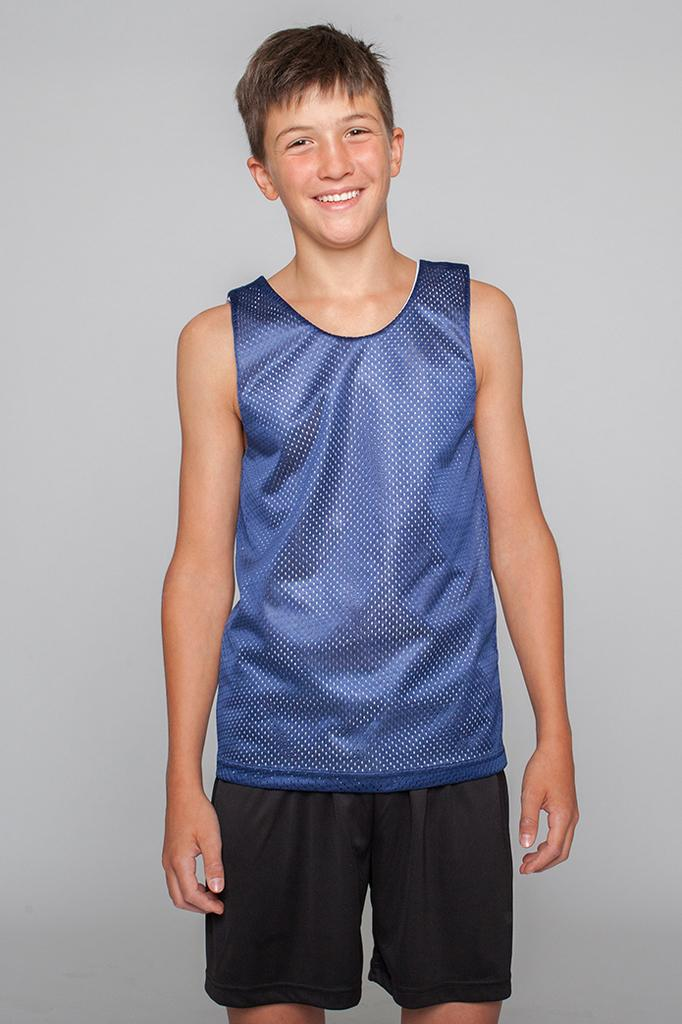What is the main subject of the picture? The main subject of the picture is a boy. What is the boy doing in the picture? The boy is standing in the picture. How does the boy appear to be feeling in the picture? The boy has a smile on his face, indicating that he is happy. What can be seen behind the boy in the picture? The background of the image is plain. What type of jeans is the boy wearing in the picture? There is no information about the boy's clothing in the image, so it cannot be determined if he is wearing jeans or any other type of clothing. 